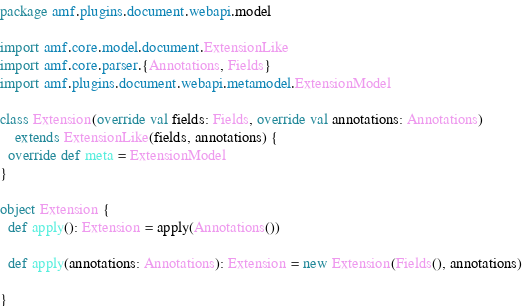<code> <loc_0><loc_0><loc_500><loc_500><_Scala_>package amf.plugins.document.webapi.model

import amf.core.model.document.ExtensionLike
import amf.core.parser.{Annotations, Fields}
import amf.plugins.document.webapi.metamodel.ExtensionModel

class Extension(override val fields: Fields, override val annotations: Annotations)
    extends ExtensionLike(fields, annotations) {
  override def meta = ExtensionModel
}

object Extension {
  def apply(): Extension = apply(Annotations())

  def apply(annotations: Annotations): Extension = new Extension(Fields(), annotations)

}</code> 